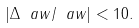<formula> <loc_0><loc_0><loc_500><loc_500>\left | \Delta \ a w / \ a w \right | < 1 0 .</formula> 